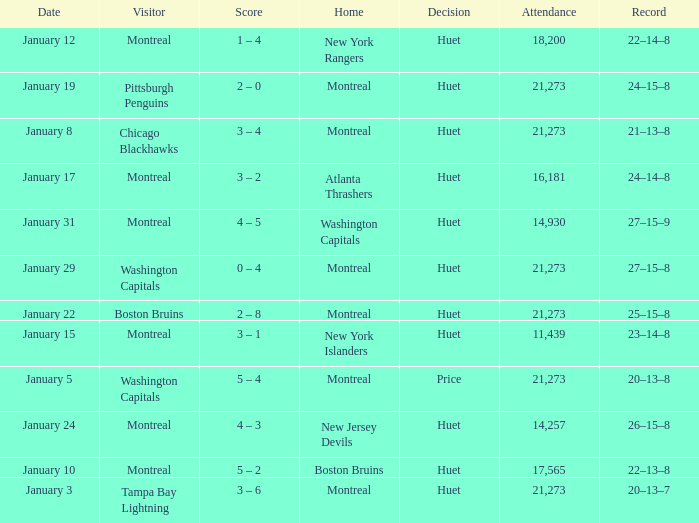When was the game with a final score of 3-1 held? January 15. 